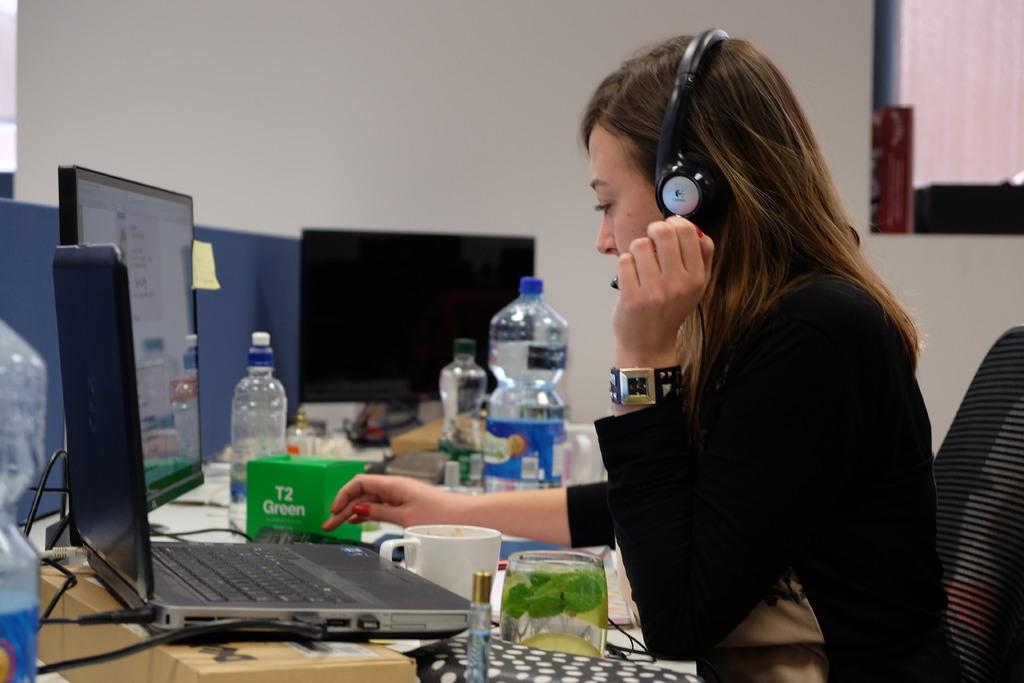<image>
Create a compact narrative representing the image presented. Sitting in front of a desk and computer is a woman wearing a headset, with a green box of T2 Green tea next to her. 